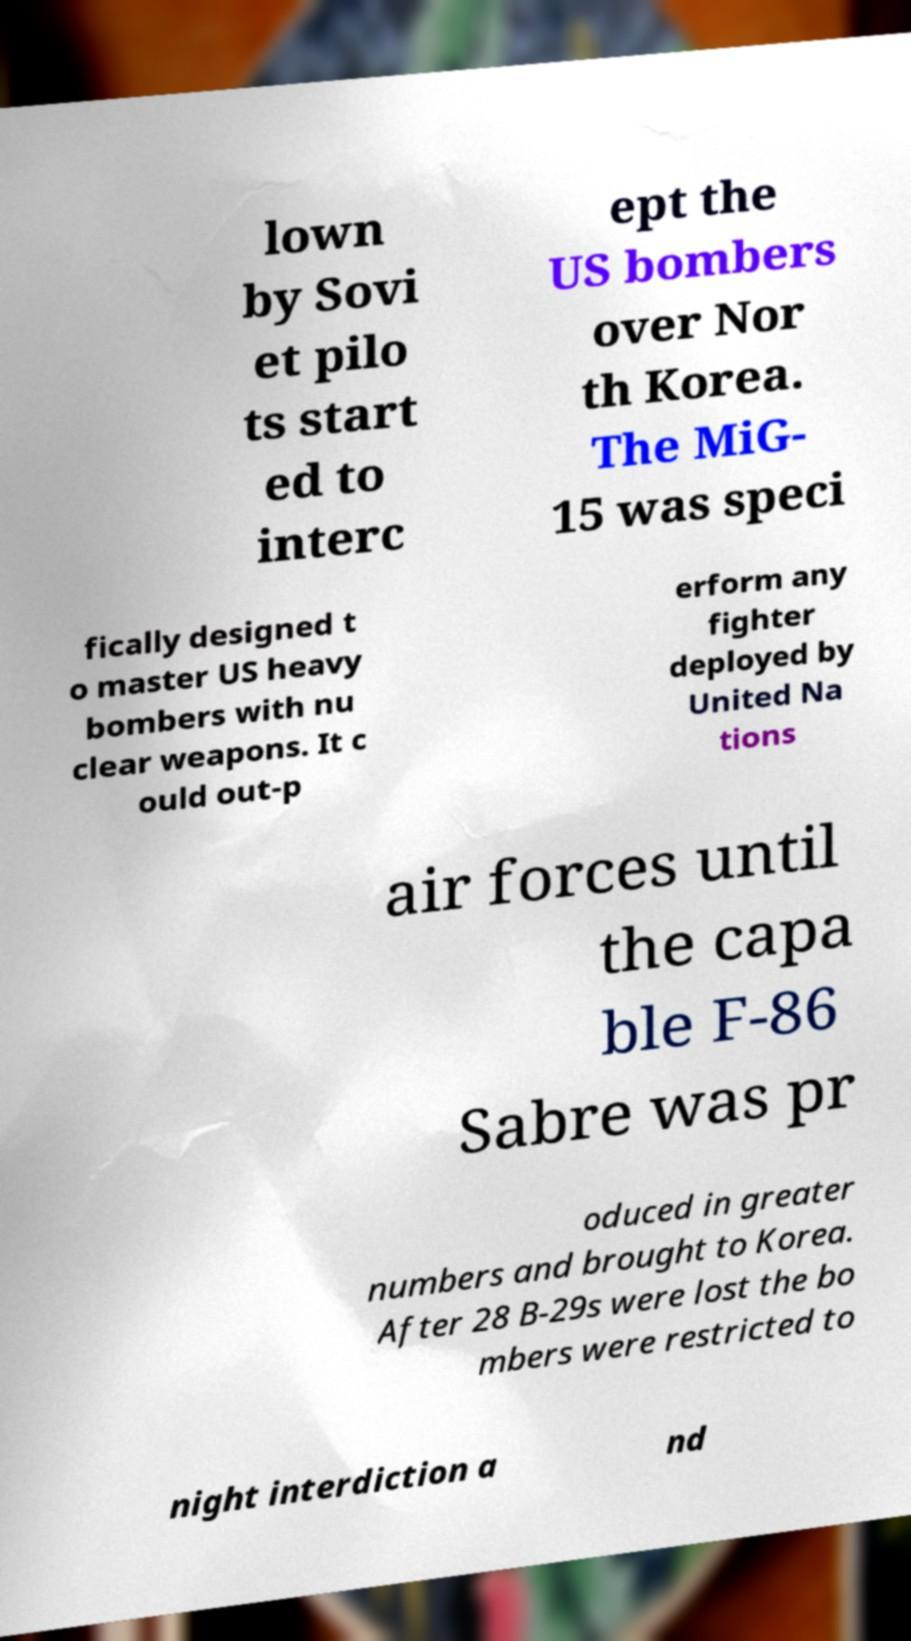Can you accurately transcribe the text from the provided image for me? lown by Sovi et pilo ts start ed to interc ept the US bombers over Nor th Korea. The MiG- 15 was speci fically designed t o master US heavy bombers with nu clear weapons. It c ould out-p erform any fighter deployed by United Na tions air forces until the capa ble F-86 Sabre was pr oduced in greater numbers and brought to Korea. After 28 B-29s were lost the bo mbers were restricted to night interdiction a nd 